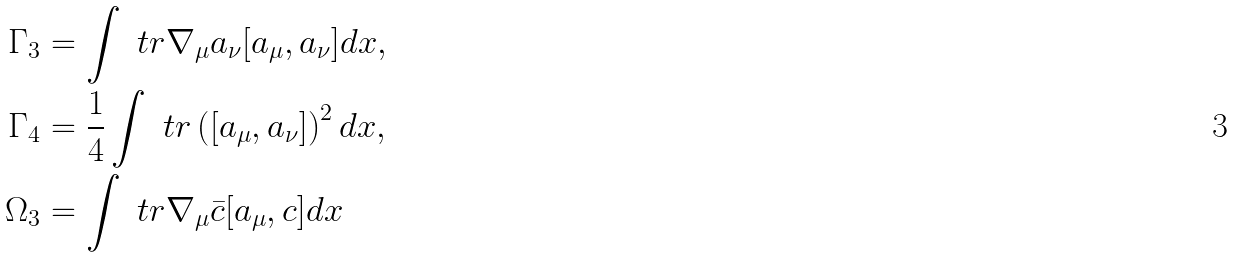<formula> <loc_0><loc_0><loc_500><loc_500>\Gamma _ { 3 } & = \int \ t r \nabla _ { \mu } a _ { \nu } [ a _ { \mu } , a _ { \nu } ] d x , \\ \Gamma _ { 4 } & = \frac { 1 } { 4 } \int \ t r \left ( [ a _ { \mu } , a _ { \nu } ] \right ) ^ { 2 } d x , \\ \Omega _ { 3 } & = \int \ t r \nabla _ { \mu } \bar { c } [ a _ { \mu } , c ] d x</formula> 